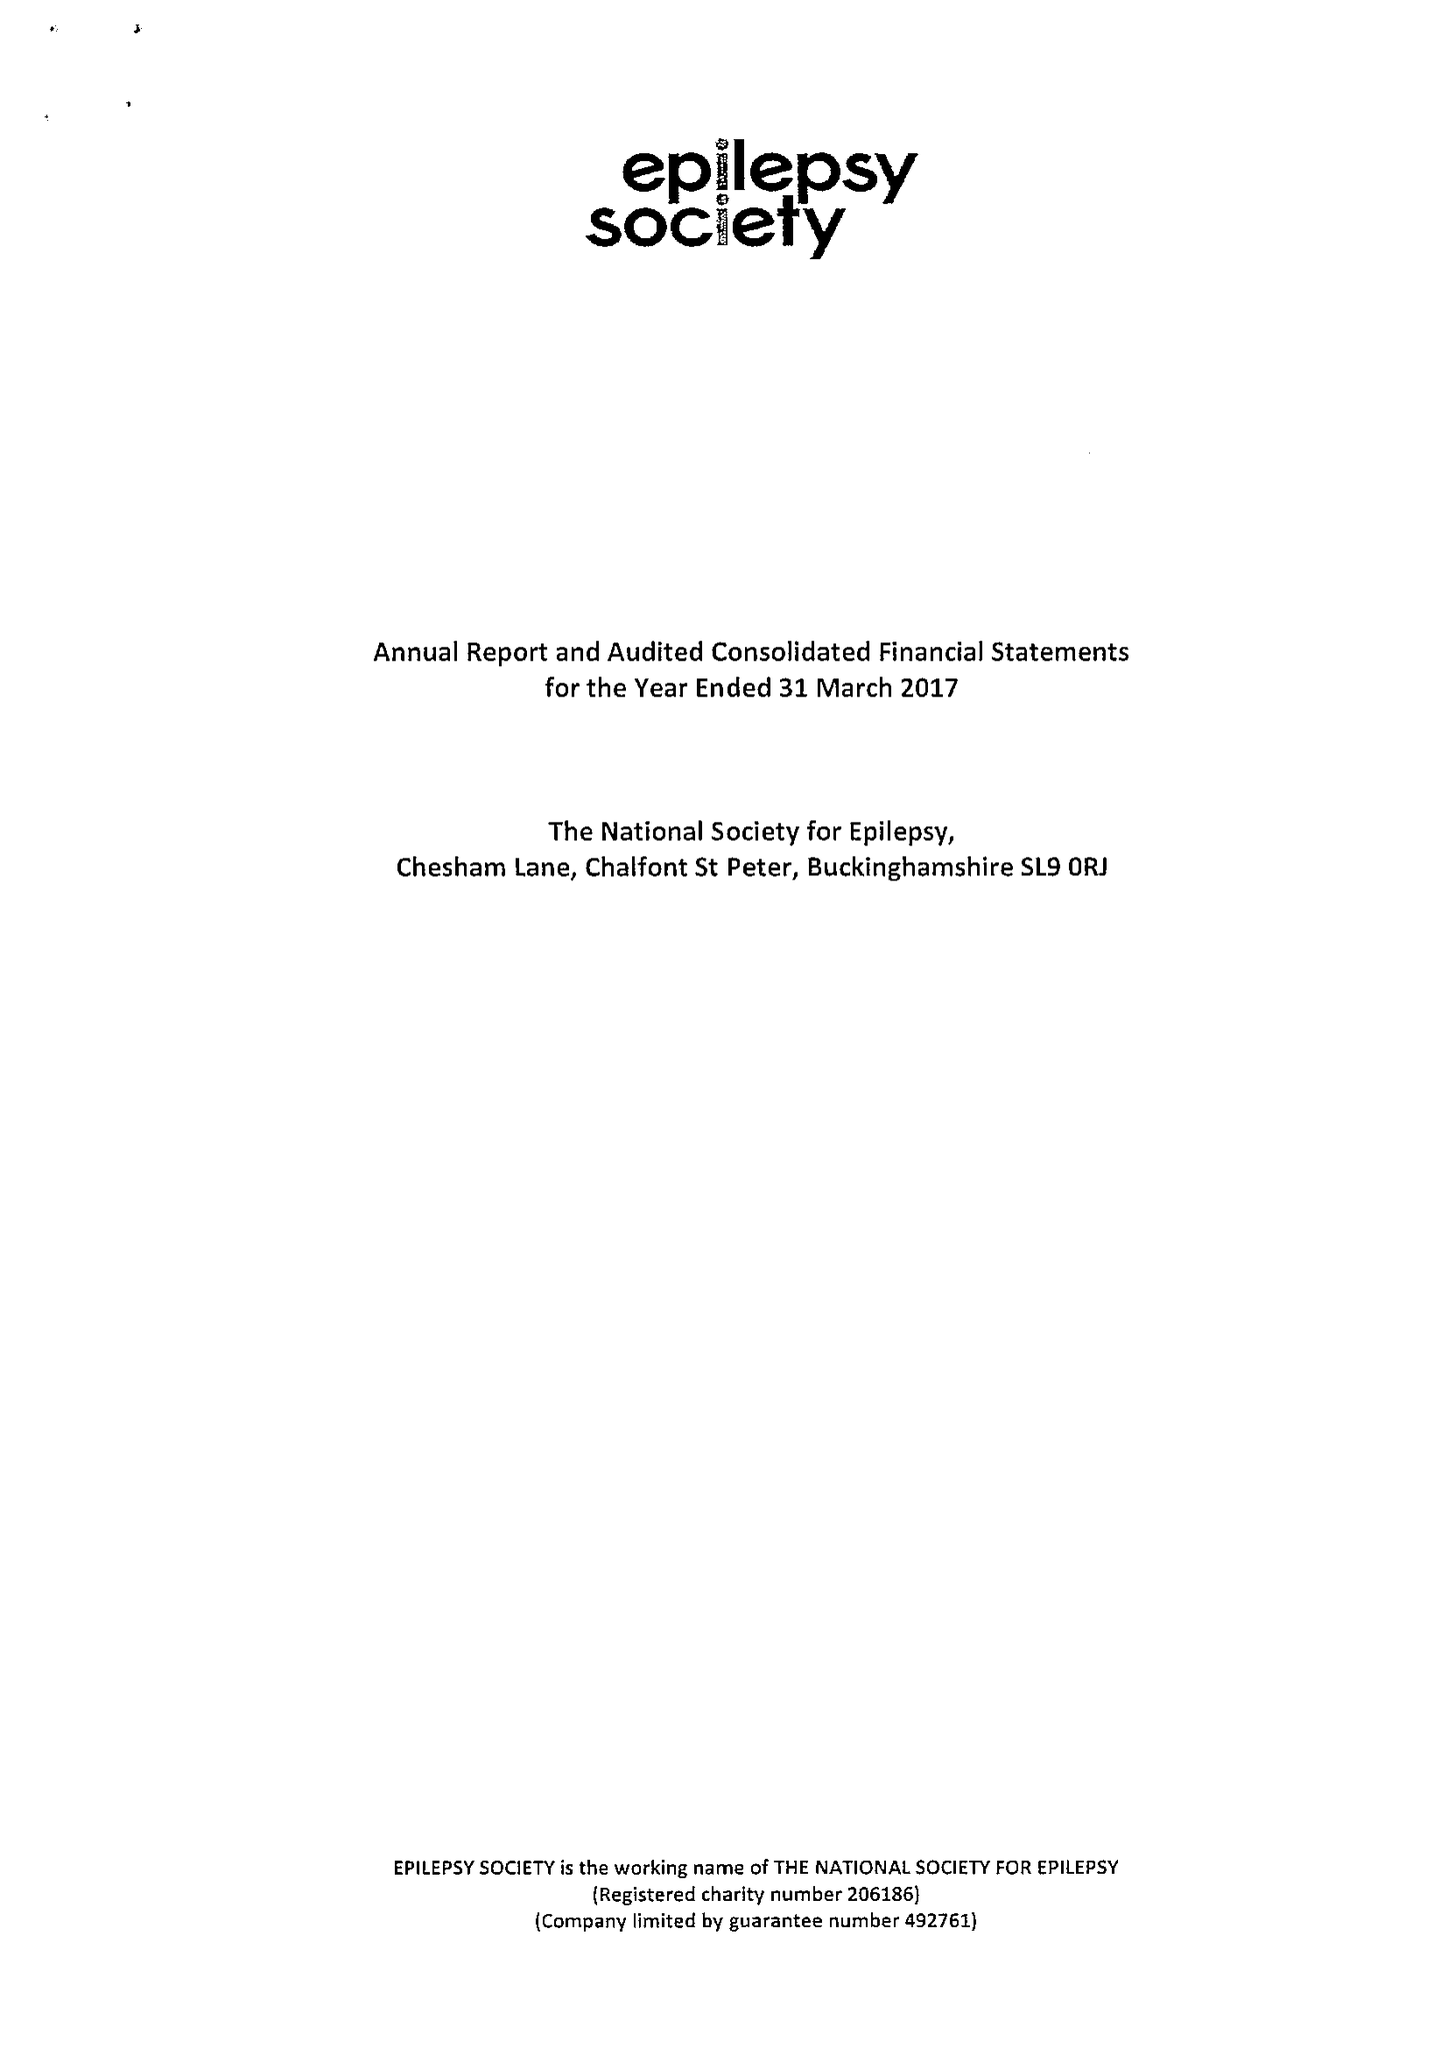What is the value for the address__post_town?
Answer the question using a single word or phrase. GERRARDS CROSS 